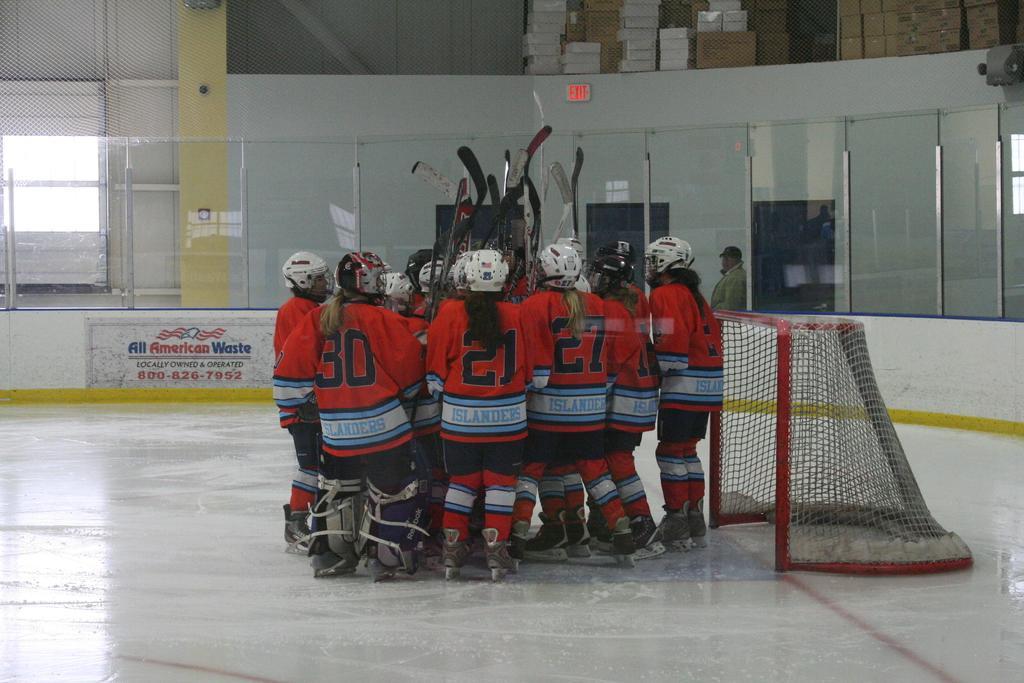Could you give a brief overview of what you see in this image? There is a group of players standing on the floor and holding bats as we can see in the middle of this image. We can see a goal on the right side of this image. The wall is in the background. 